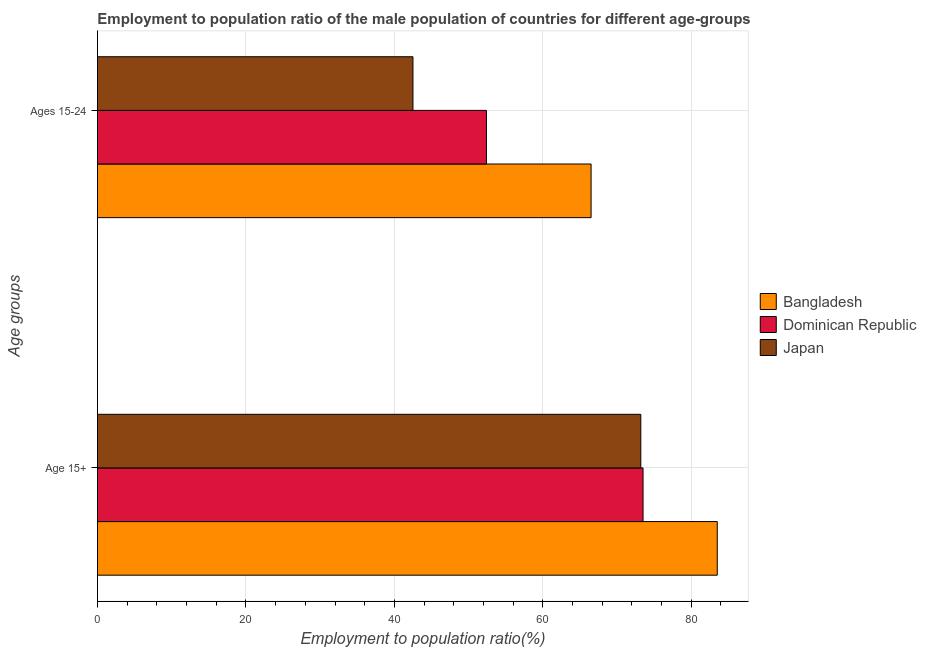How many groups of bars are there?
Your response must be concise. 2. Are the number of bars per tick equal to the number of legend labels?
Offer a very short reply. Yes. Are the number of bars on each tick of the Y-axis equal?
Give a very brief answer. Yes. What is the label of the 2nd group of bars from the top?
Offer a terse response. Age 15+. What is the employment to population ratio(age 15+) in Dominican Republic?
Your answer should be compact. 73.5. Across all countries, what is the maximum employment to population ratio(age 15+)?
Keep it short and to the point. 83.5. Across all countries, what is the minimum employment to population ratio(age 15+)?
Offer a very short reply. 73.2. In which country was the employment to population ratio(age 15-24) maximum?
Offer a terse response. Bangladesh. What is the total employment to population ratio(age 15-24) in the graph?
Ensure brevity in your answer.  161.4. What is the difference between the employment to population ratio(age 15+) in Bangladesh and that in Dominican Republic?
Keep it short and to the point. 10. What is the average employment to population ratio(age 15-24) per country?
Provide a short and direct response. 53.8. What is the difference between the employment to population ratio(age 15-24) and employment to population ratio(age 15+) in Japan?
Provide a succinct answer. -30.7. What is the ratio of the employment to population ratio(age 15-24) in Japan to that in Dominican Republic?
Your response must be concise. 0.81. Is the employment to population ratio(age 15+) in Bangladesh less than that in Dominican Republic?
Provide a short and direct response. No. In how many countries, is the employment to population ratio(age 15+) greater than the average employment to population ratio(age 15+) taken over all countries?
Give a very brief answer. 1. What does the 3rd bar from the top in Ages 15-24 represents?
Provide a succinct answer. Bangladesh. How many bars are there?
Your answer should be very brief. 6. How many countries are there in the graph?
Keep it short and to the point. 3. What is the difference between two consecutive major ticks on the X-axis?
Your answer should be very brief. 20. Are the values on the major ticks of X-axis written in scientific E-notation?
Keep it short and to the point. No. How many legend labels are there?
Offer a very short reply. 3. How are the legend labels stacked?
Ensure brevity in your answer.  Vertical. What is the title of the graph?
Your response must be concise. Employment to population ratio of the male population of countries for different age-groups. What is the label or title of the Y-axis?
Provide a short and direct response. Age groups. What is the Employment to population ratio(%) of Bangladesh in Age 15+?
Make the answer very short. 83.5. What is the Employment to population ratio(%) of Dominican Republic in Age 15+?
Make the answer very short. 73.5. What is the Employment to population ratio(%) in Japan in Age 15+?
Give a very brief answer. 73.2. What is the Employment to population ratio(%) of Bangladesh in Ages 15-24?
Give a very brief answer. 66.5. What is the Employment to population ratio(%) of Dominican Republic in Ages 15-24?
Keep it short and to the point. 52.4. What is the Employment to population ratio(%) of Japan in Ages 15-24?
Give a very brief answer. 42.5. Across all Age groups, what is the maximum Employment to population ratio(%) of Bangladesh?
Your answer should be very brief. 83.5. Across all Age groups, what is the maximum Employment to population ratio(%) in Dominican Republic?
Offer a terse response. 73.5. Across all Age groups, what is the maximum Employment to population ratio(%) of Japan?
Provide a succinct answer. 73.2. Across all Age groups, what is the minimum Employment to population ratio(%) of Bangladesh?
Your answer should be very brief. 66.5. Across all Age groups, what is the minimum Employment to population ratio(%) of Dominican Republic?
Offer a very short reply. 52.4. Across all Age groups, what is the minimum Employment to population ratio(%) of Japan?
Your answer should be very brief. 42.5. What is the total Employment to population ratio(%) in Bangladesh in the graph?
Provide a short and direct response. 150. What is the total Employment to population ratio(%) in Dominican Republic in the graph?
Your answer should be compact. 125.9. What is the total Employment to population ratio(%) of Japan in the graph?
Offer a terse response. 115.7. What is the difference between the Employment to population ratio(%) in Dominican Republic in Age 15+ and that in Ages 15-24?
Your answer should be compact. 21.1. What is the difference between the Employment to population ratio(%) of Japan in Age 15+ and that in Ages 15-24?
Offer a very short reply. 30.7. What is the difference between the Employment to population ratio(%) in Bangladesh in Age 15+ and the Employment to population ratio(%) in Dominican Republic in Ages 15-24?
Your answer should be very brief. 31.1. What is the average Employment to population ratio(%) in Dominican Republic per Age groups?
Ensure brevity in your answer.  62.95. What is the average Employment to population ratio(%) of Japan per Age groups?
Give a very brief answer. 57.85. What is the difference between the Employment to population ratio(%) in Bangladesh and Employment to population ratio(%) in Dominican Republic in Ages 15-24?
Provide a succinct answer. 14.1. What is the difference between the Employment to population ratio(%) of Dominican Republic and Employment to population ratio(%) of Japan in Ages 15-24?
Your response must be concise. 9.9. What is the ratio of the Employment to population ratio(%) of Bangladesh in Age 15+ to that in Ages 15-24?
Give a very brief answer. 1.26. What is the ratio of the Employment to population ratio(%) of Dominican Republic in Age 15+ to that in Ages 15-24?
Keep it short and to the point. 1.4. What is the ratio of the Employment to population ratio(%) of Japan in Age 15+ to that in Ages 15-24?
Offer a very short reply. 1.72. What is the difference between the highest and the second highest Employment to population ratio(%) of Bangladesh?
Provide a short and direct response. 17. What is the difference between the highest and the second highest Employment to population ratio(%) in Dominican Republic?
Your answer should be compact. 21.1. What is the difference between the highest and the second highest Employment to population ratio(%) in Japan?
Provide a succinct answer. 30.7. What is the difference between the highest and the lowest Employment to population ratio(%) of Bangladesh?
Your answer should be very brief. 17. What is the difference between the highest and the lowest Employment to population ratio(%) in Dominican Republic?
Your response must be concise. 21.1. What is the difference between the highest and the lowest Employment to population ratio(%) of Japan?
Keep it short and to the point. 30.7. 